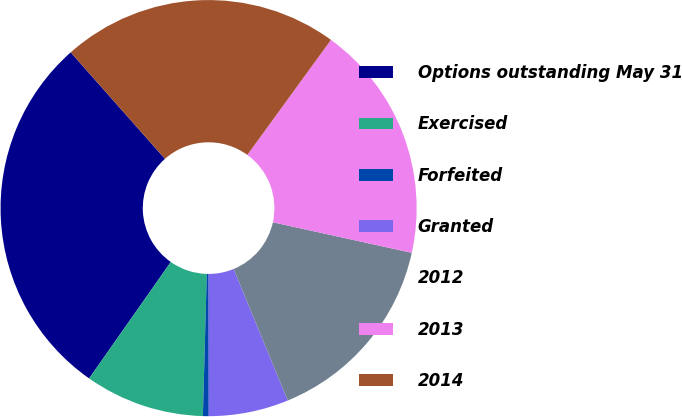Convert chart to OTSL. <chart><loc_0><loc_0><loc_500><loc_500><pie_chart><fcel>Options outstanding May 31<fcel>Exercised<fcel>Forfeited<fcel>Granted<fcel>2012<fcel>2013<fcel>2014<nl><fcel>28.73%<fcel>9.3%<fcel>0.45%<fcel>6.2%<fcel>15.34%<fcel>18.44%<fcel>21.54%<nl></chart> 